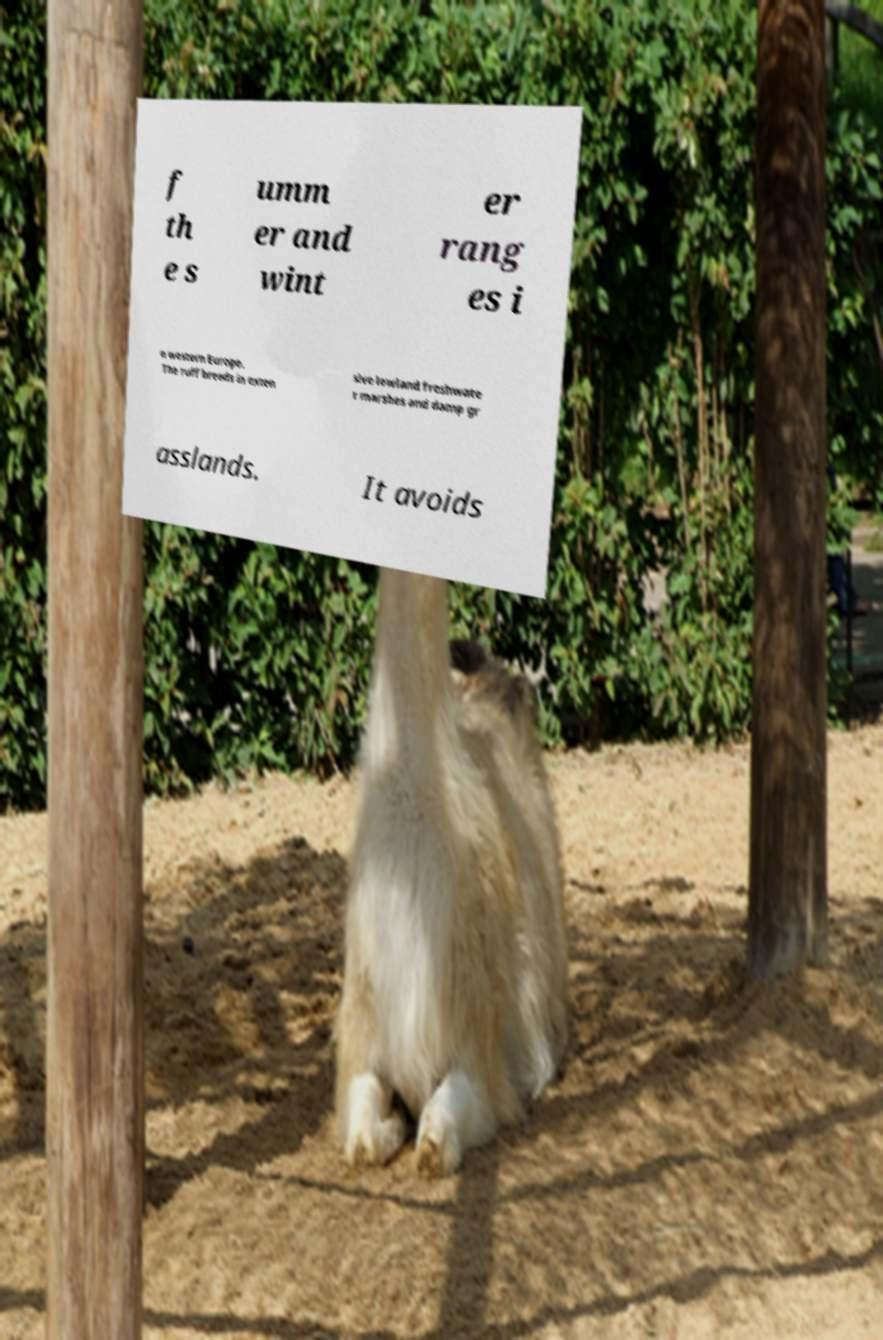I need the written content from this picture converted into text. Can you do that? f th e s umm er and wint er rang es i n western Europe. The ruff breeds in exten sive lowland freshwate r marshes and damp gr asslands. It avoids 